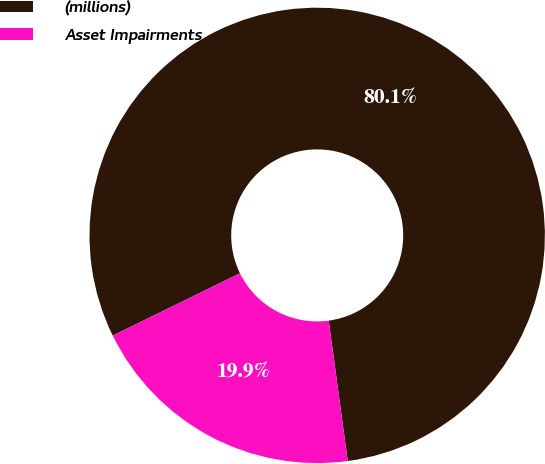Convert chart. <chart><loc_0><loc_0><loc_500><loc_500><pie_chart><fcel>(millions)<fcel>Asset Impairments<nl><fcel>80.11%<fcel>19.89%<nl></chart> 